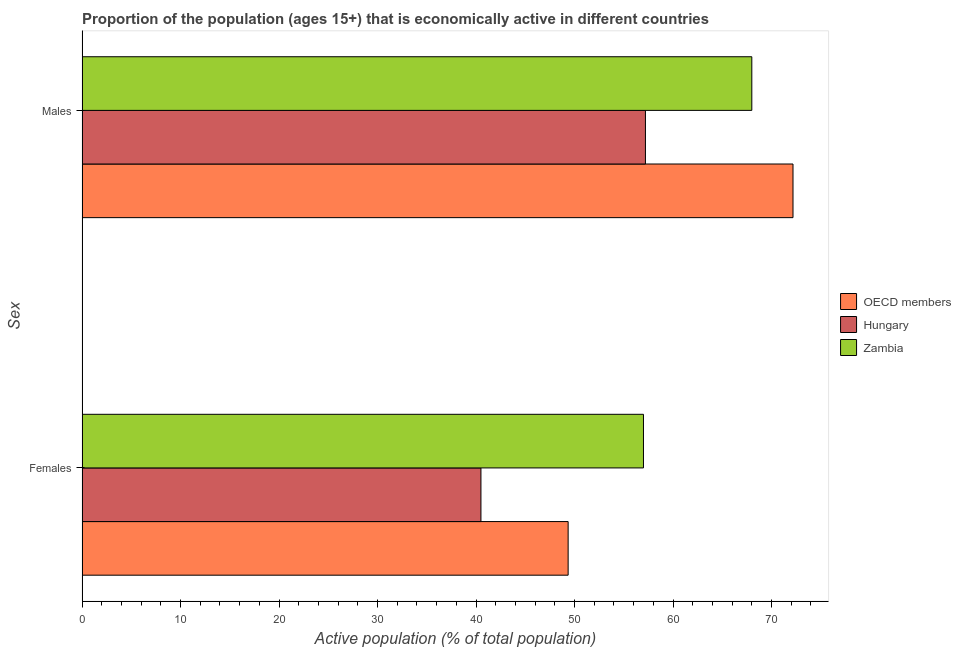How many different coloured bars are there?
Offer a terse response. 3. How many groups of bars are there?
Ensure brevity in your answer.  2. How many bars are there on the 1st tick from the bottom?
Offer a terse response. 3. What is the label of the 1st group of bars from the top?
Offer a terse response. Males. What is the percentage of economically active female population in Hungary?
Keep it short and to the point. 40.5. Across all countries, what is the maximum percentage of economically active male population?
Offer a terse response. 72.18. Across all countries, what is the minimum percentage of economically active male population?
Offer a very short reply. 57.2. In which country was the percentage of economically active female population maximum?
Your response must be concise. Zambia. In which country was the percentage of economically active male population minimum?
Offer a terse response. Hungary. What is the total percentage of economically active female population in the graph?
Provide a succinct answer. 146.85. What is the difference between the percentage of economically active female population in OECD members and that in Zambia?
Keep it short and to the point. -7.65. What is the difference between the percentage of economically active male population in Hungary and the percentage of economically active female population in Zambia?
Keep it short and to the point. 0.2. What is the average percentage of economically active female population per country?
Keep it short and to the point. 48.95. What is the difference between the percentage of economically active female population and percentage of economically active male population in Hungary?
Give a very brief answer. -16.7. In how many countries, is the percentage of economically active female population greater than 2 %?
Your response must be concise. 3. What is the ratio of the percentage of economically active female population in Zambia to that in OECD members?
Provide a succinct answer. 1.15. Is the percentage of economically active male population in OECD members less than that in Zambia?
Provide a short and direct response. No. In how many countries, is the percentage of economically active female population greater than the average percentage of economically active female population taken over all countries?
Offer a terse response. 2. What does the 1st bar from the top in Males represents?
Provide a short and direct response. Zambia. What does the 1st bar from the bottom in Females represents?
Offer a very short reply. OECD members. How many countries are there in the graph?
Provide a succinct answer. 3. What is the difference between two consecutive major ticks on the X-axis?
Offer a very short reply. 10. Are the values on the major ticks of X-axis written in scientific E-notation?
Ensure brevity in your answer.  No. Does the graph contain grids?
Your answer should be very brief. No. Where does the legend appear in the graph?
Provide a short and direct response. Center right. How many legend labels are there?
Keep it short and to the point. 3. What is the title of the graph?
Ensure brevity in your answer.  Proportion of the population (ages 15+) that is economically active in different countries. Does "Low & middle income" appear as one of the legend labels in the graph?
Your answer should be very brief. No. What is the label or title of the X-axis?
Your response must be concise. Active population (% of total population). What is the label or title of the Y-axis?
Keep it short and to the point. Sex. What is the Active population (% of total population) in OECD members in Females?
Your answer should be compact. 49.35. What is the Active population (% of total population) of Hungary in Females?
Your answer should be compact. 40.5. What is the Active population (% of total population) in Zambia in Females?
Offer a very short reply. 57. What is the Active population (% of total population) of OECD members in Males?
Give a very brief answer. 72.18. What is the Active population (% of total population) of Hungary in Males?
Keep it short and to the point. 57.2. What is the Active population (% of total population) in Zambia in Males?
Your answer should be very brief. 68. Across all Sex, what is the maximum Active population (% of total population) of OECD members?
Provide a short and direct response. 72.18. Across all Sex, what is the maximum Active population (% of total population) in Hungary?
Your answer should be very brief. 57.2. Across all Sex, what is the minimum Active population (% of total population) in OECD members?
Provide a succinct answer. 49.35. Across all Sex, what is the minimum Active population (% of total population) in Hungary?
Offer a very short reply. 40.5. Across all Sex, what is the minimum Active population (% of total population) in Zambia?
Your answer should be compact. 57. What is the total Active population (% of total population) of OECD members in the graph?
Your response must be concise. 121.54. What is the total Active population (% of total population) in Hungary in the graph?
Your response must be concise. 97.7. What is the total Active population (% of total population) of Zambia in the graph?
Offer a very short reply. 125. What is the difference between the Active population (% of total population) in OECD members in Females and that in Males?
Keep it short and to the point. -22.83. What is the difference between the Active population (% of total population) of Hungary in Females and that in Males?
Provide a succinct answer. -16.7. What is the difference between the Active population (% of total population) in OECD members in Females and the Active population (% of total population) in Hungary in Males?
Give a very brief answer. -7.85. What is the difference between the Active population (% of total population) of OECD members in Females and the Active population (% of total population) of Zambia in Males?
Keep it short and to the point. -18.65. What is the difference between the Active population (% of total population) in Hungary in Females and the Active population (% of total population) in Zambia in Males?
Give a very brief answer. -27.5. What is the average Active population (% of total population) in OECD members per Sex?
Provide a succinct answer. 60.77. What is the average Active population (% of total population) in Hungary per Sex?
Your answer should be compact. 48.85. What is the average Active population (% of total population) in Zambia per Sex?
Offer a terse response. 62.5. What is the difference between the Active population (% of total population) in OECD members and Active population (% of total population) in Hungary in Females?
Provide a short and direct response. 8.85. What is the difference between the Active population (% of total population) of OECD members and Active population (% of total population) of Zambia in Females?
Make the answer very short. -7.65. What is the difference between the Active population (% of total population) of Hungary and Active population (% of total population) of Zambia in Females?
Offer a very short reply. -16.5. What is the difference between the Active population (% of total population) of OECD members and Active population (% of total population) of Hungary in Males?
Ensure brevity in your answer.  14.98. What is the difference between the Active population (% of total population) of OECD members and Active population (% of total population) of Zambia in Males?
Give a very brief answer. 4.18. What is the difference between the Active population (% of total population) in Hungary and Active population (% of total population) in Zambia in Males?
Provide a succinct answer. -10.8. What is the ratio of the Active population (% of total population) in OECD members in Females to that in Males?
Keep it short and to the point. 0.68. What is the ratio of the Active population (% of total population) of Hungary in Females to that in Males?
Provide a short and direct response. 0.71. What is the ratio of the Active population (% of total population) of Zambia in Females to that in Males?
Offer a terse response. 0.84. What is the difference between the highest and the second highest Active population (% of total population) in OECD members?
Make the answer very short. 22.83. What is the difference between the highest and the second highest Active population (% of total population) of Zambia?
Keep it short and to the point. 11. What is the difference between the highest and the lowest Active population (% of total population) of OECD members?
Provide a succinct answer. 22.83. What is the difference between the highest and the lowest Active population (% of total population) in Hungary?
Your answer should be very brief. 16.7. What is the difference between the highest and the lowest Active population (% of total population) of Zambia?
Your response must be concise. 11. 